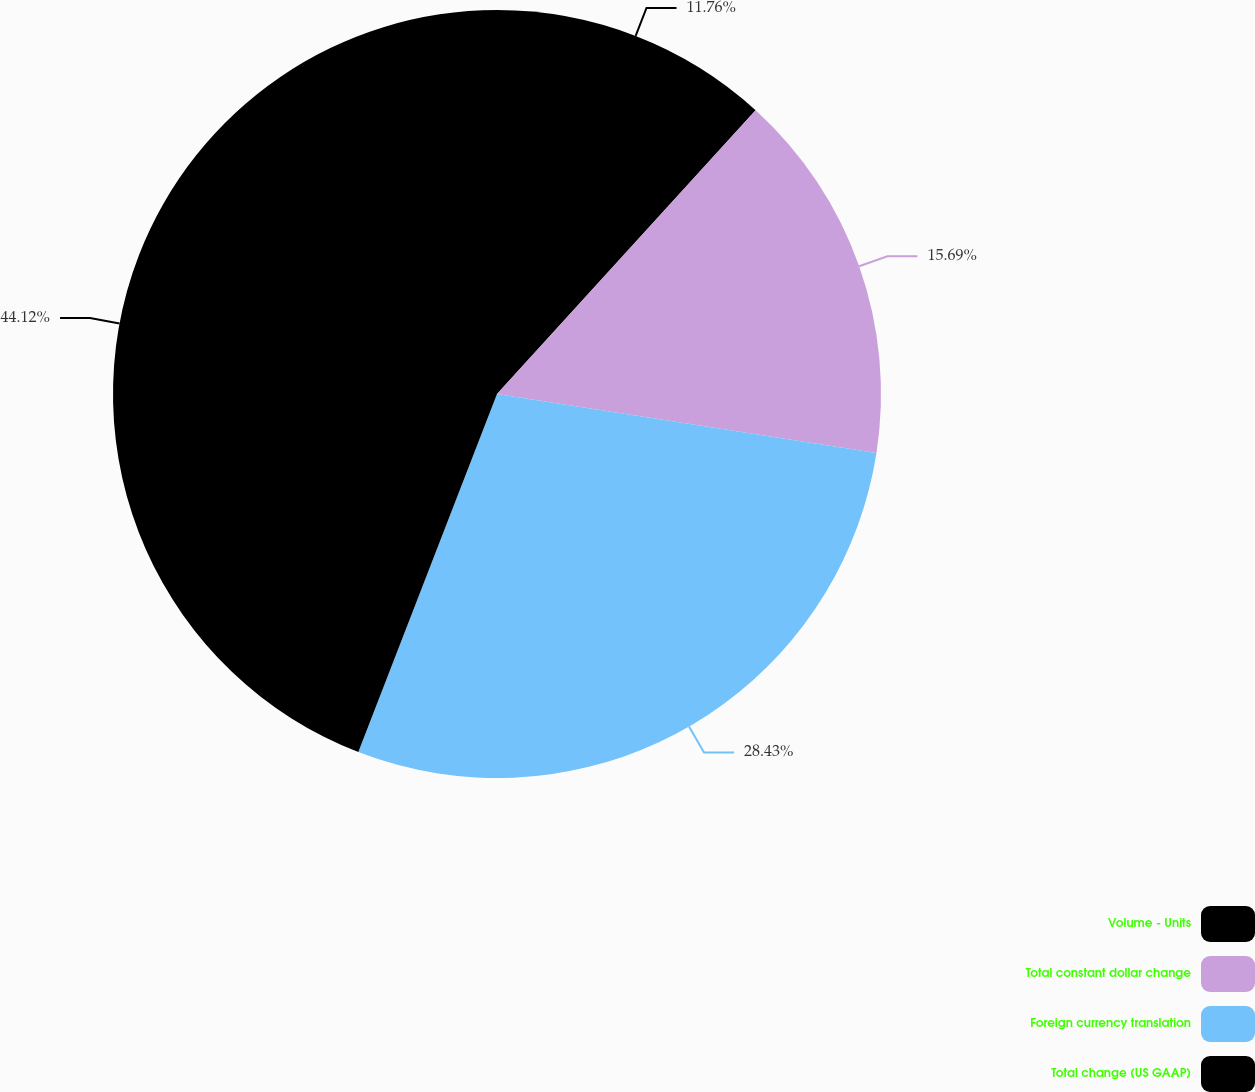Convert chart to OTSL. <chart><loc_0><loc_0><loc_500><loc_500><pie_chart><fcel>Volume - Units<fcel>Total constant dollar change<fcel>Foreign currency translation<fcel>Total change (US GAAP)<nl><fcel>11.76%<fcel>15.69%<fcel>28.43%<fcel>44.12%<nl></chart> 